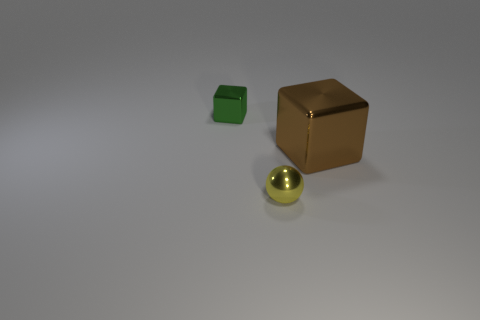What can you infer about the setting or environment where these objects are placed? The objects appear to be resting on a smooth, flat surface with a neutral color, which could imply an indoor setting, such as a studio for product photography. The lack of any discernible background features suggests the focus is intended to be on the objects themselves. 